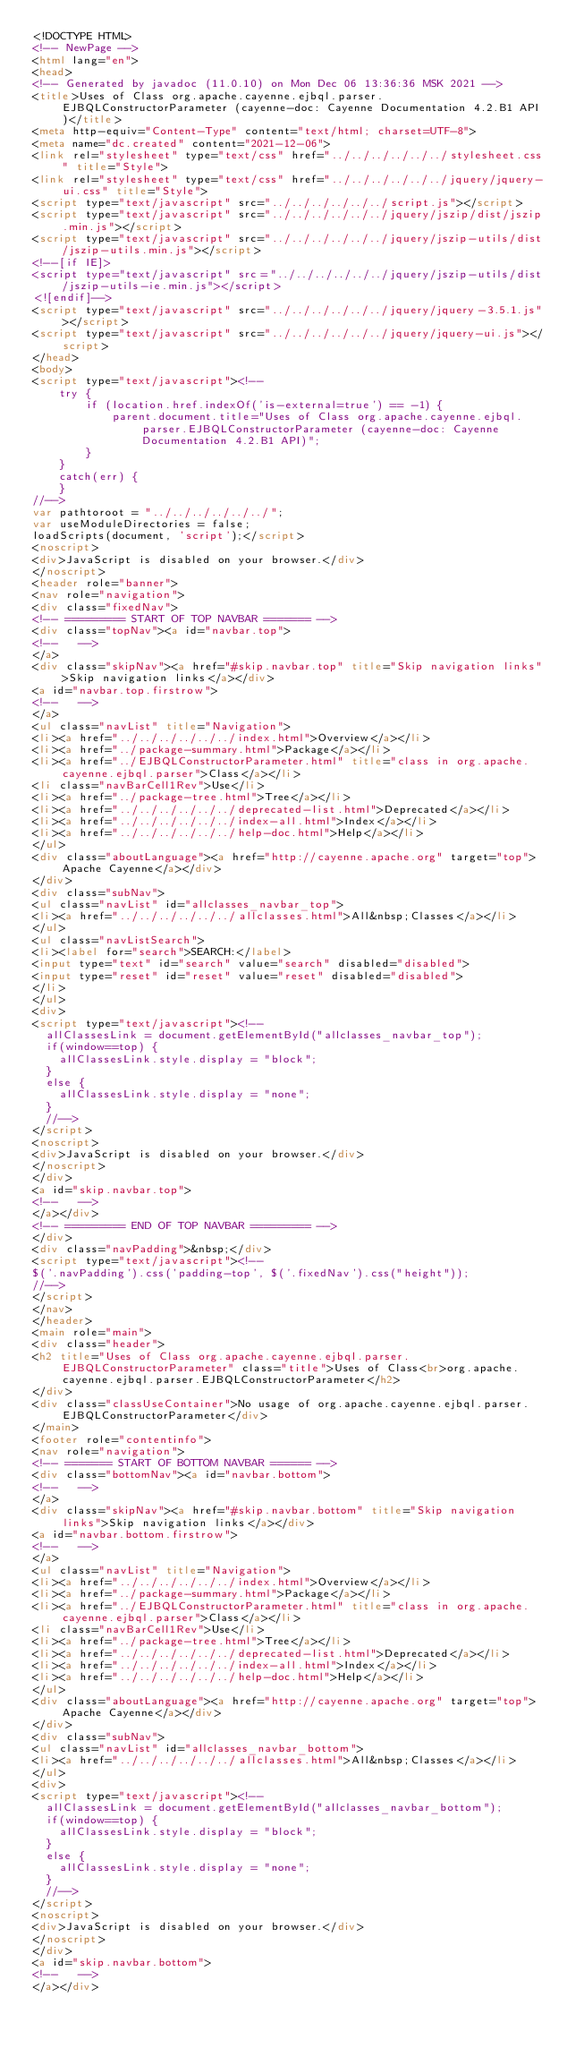<code> <loc_0><loc_0><loc_500><loc_500><_HTML_><!DOCTYPE HTML>
<!-- NewPage -->
<html lang="en">
<head>
<!-- Generated by javadoc (11.0.10) on Mon Dec 06 13:36:36 MSK 2021 -->
<title>Uses of Class org.apache.cayenne.ejbql.parser.EJBQLConstructorParameter (cayenne-doc: Cayenne Documentation 4.2.B1 API)</title>
<meta http-equiv="Content-Type" content="text/html; charset=UTF-8">
<meta name="dc.created" content="2021-12-06">
<link rel="stylesheet" type="text/css" href="../../../../../../stylesheet.css" title="Style">
<link rel="stylesheet" type="text/css" href="../../../../../../jquery/jquery-ui.css" title="Style">
<script type="text/javascript" src="../../../../../../script.js"></script>
<script type="text/javascript" src="../../../../../../jquery/jszip/dist/jszip.min.js"></script>
<script type="text/javascript" src="../../../../../../jquery/jszip-utils/dist/jszip-utils.min.js"></script>
<!--[if IE]>
<script type="text/javascript" src="../../../../../../jquery/jszip-utils/dist/jszip-utils-ie.min.js"></script>
<![endif]-->
<script type="text/javascript" src="../../../../../../jquery/jquery-3.5.1.js"></script>
<script type="text/javascript" src="../../../../../../jquery/jquery-ui.js"></script>
</head>
<body>
<script type="text/javascript"><!--
    try {
        if (location.href.indexOf('is-external=true') == -1) {
            parent.document.title="Uses of Class org.apache.cayenne.ejbql.parser.EJBQLConstructorParameter (cayenne-doc: Cayenne Documentation 4.2.B1 API)";
        }
    }
    catch(err) {
    }
//-->
var pathtoroot = "../../../../../../";
var useModuleDirectories = false;
loadScripts(document, 'script');</script>
<noscript>
<div>JavaScript is disabled on your browser.</div>
</noscript>
<header role="banner">
<nav role="navigation">
<div class="fixedNav">
<!-- ========= START OF TOP NAVBAR ======= -->
<div class="topNav"><a id="navbar.top">
<!--   -->
</a>
<div class="skipNav"><a href="#skip.navbar.top" title="Skip navigation links">Skip navigation links</a></div>
<a id="navbar.top.firstrow">
<!--   -->
</a>
<ul class="navList" title="Navigation">
<li><a href="../../../../../../index.html">Overview</a></li>
<li><a href="../package-summary.html">Package</a></li>
<li><a href="../EJBQLConstructorParameter.html" title="class in org.apache.cayenne.ejbql.parser">Class</a></li>
<li class="navBarCell1Rev">Use</li>
<li><a href="../package-tree.html">Tree</a></li>
<li><a href="../../../../../../deprecated-list.html">Deprecated</a></li>
<li><a href="../../../../../../index-all.html">Index</a></li>
<li><a href="../../../../../../help-doc.html">Help</a></li>
</ul>
<div class="aboutLanguage"><a href="http://cayenne.apache.org" target="top">Apache Cayenne</a></div>
</div>
<div class="subNav">
<ul class="navList" id="allclasses_navbar_top">
<li><a href="../../../../../../allclasses.html">All&nbsp;Classes</a></li>
</ul>
<ul class="navListSearch">
<li><label for="search">SEARCH:</label>
<input type="text" id="search" value="search" disabled="disabled">
<input type="reset" id="reset" value="reset" disabled="disabled">
</li>
</ul>
<div>
<script type="text/javascript"><!--
  allClassesLink = document.getElementById("allclasses_navbar_top");
  if(window==top) {
    allClassesLink.style.display = "block";
  }
  else {
    allClassesLink.style.display = "none";
  }
  //-->
</script>
<noscript>
<div>JavaScript is disabled on your browser.</div>
</noscript>
</div>
<a id="skip.navbar.top">
<!--   -->
</a></div>
<!-- ========= END OF TOP NAVBAR ========= -->
</div>
<div class="navPadding">&nbsp;</div>
<script type="text/javascript"><!--
$('.navPadding').css('padding-top', $('.fixedNav').css("height"));
//-->
</script>
</nav>
</header>
<main role="main">
<div class="header">
<h2 title="Uses of Class org.apache.cayenne.ejbql.parser.EJBQLConstructorParameter" class="title">Uses of Class<br>org.apache.cayenne.ejbql.parser.EJBQLConstructorParameter</h2>
</div>
<div class="classUseContainer">No usage of org.apache.cayenne.ejbql.parser.EJBQLConstructorParameter</div>
</main>
<footer role="contentinfo">
<nav role="navigation">
<!-- ======= START OF BOTTOM NAVBAR ====== -->
<div class="bottomNav"><a id="navbar.bottom">
<!--   -->
</a>
<div class="skipNav"><a href="#skip.navbar.bottom" title="Skip navigation links">Skip navigation links</a></div>
<a id="navbar.bottom.firstrow">
<!--   -->
</a>
<ul class="navList" title="Navigation">
<li><a href="../../../../../../index.html">Overview</a></li>
<li><a href="../package-summary.html">Package</a></li>
<li><a href="../EJBQLConstructorParameter.html" title="class in org.apache.cayenne.ejbql.parser">Class</a></li>
<li class="navBarCell1Rev">Use</li>
<li><a href="../package-tree.html">Tree</a></li>
<li><a href="../../../../../../deprecated-list.html">Deprecated</a></li>
<li><a href="../../../../../../index-all.html">Index</a></li>
<li><a href="../../../../../../help-doc.html">Help</a></li>
</ul>
<div class="aboutLanguage"><a href="http://cayenne.apache.org" target="top">Apache Cayenne</a></div>
</div>
<div class="subNav">
<ul class="navList" id="allclasses_navbar_bottom">
<li><a href="../../../../../../allclasses.html">All&nbsp;Classes</a></li>
</ul>
<div>
<script type="text/javascript"><!--
  allClassesLink = document.getElementById("allclasses_navbar_bottom");
  if(window==top) {
    allClassesLink.style.display = "block";
  }
  else {
    allClassesLink.style.display = "none";
  }
  //-->
</script>
<noscript>
<div>JavaScript is disabled on your browser.</div>
</noscript>
</div>
<a id="skip.navbar.bottom">
<!--   -->
</a></div></code> 